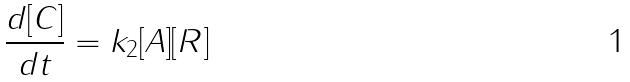<formula> <loc_0><loc_0><loc_500><loc_500>\frac { d [ C ] } { d t } = k _ { 2 } [ A ] [ R ]</formula> 